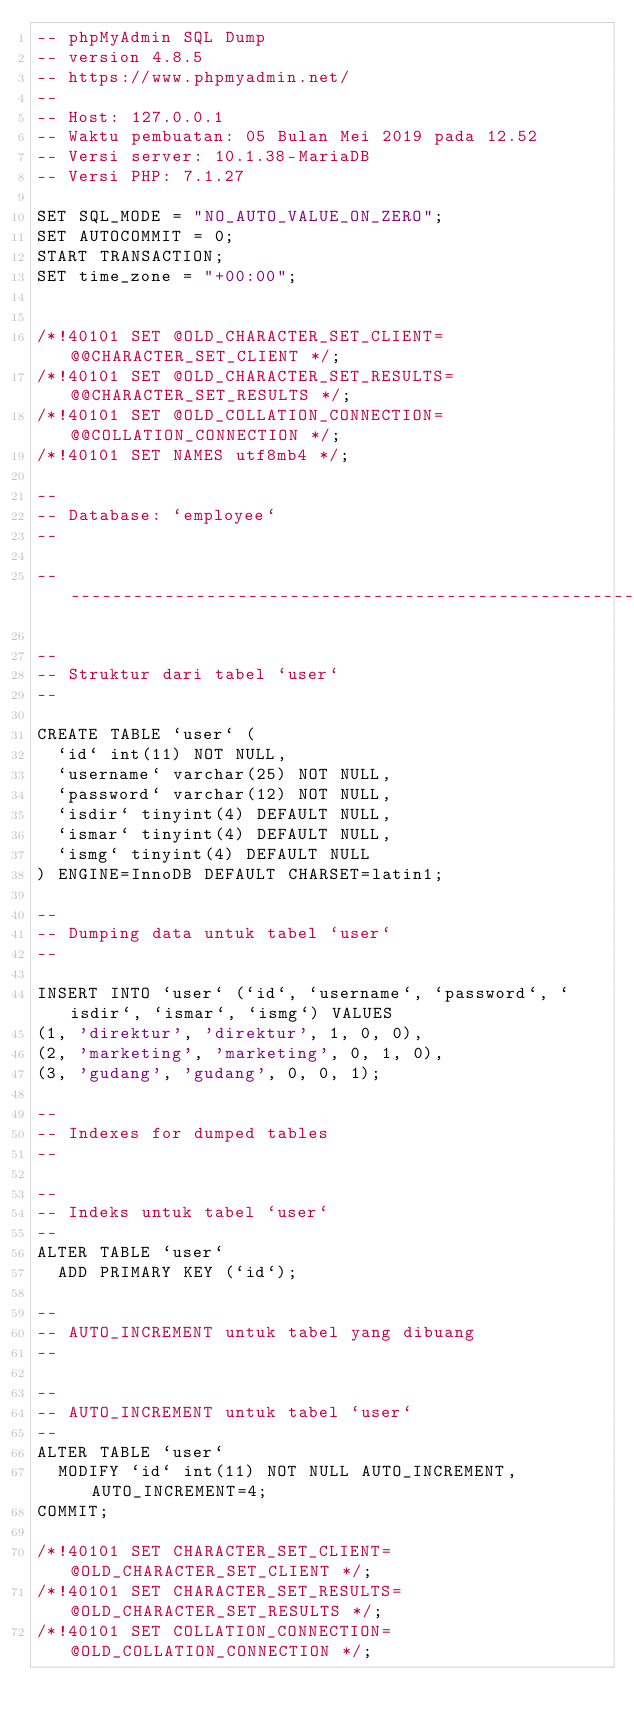Convert code to text. <code><loc_0><loc_0><loc_500><loc_500><_SQL_>-- phpMyAdmin SQL Dump
-- version 4.8.5
-- https://www.phpmyadmin.net/
--
-- Host: 127.0.0.1
-- Waktu pembuatan: 05 Bulan Mei 2019 pada 12.52
-- Versi server: 10.1.38-MariaDB
-- Versi PHP: 7.1.27

SET SQL_MODE = "NO_AUTO_VALUE_ON_ZERO";
SET AUTOCOMMIT = 0;
START TRANSACTION;
SET time_zone = "+00:00";


/*!40101 SET @OLD_CHARACTER_SET_CLIENT=@@CHARACTER_SET_CLIENT */;
/*!40101 SET @OLD_CHARACTER_SET_RESULTS=@@CHARACTER_SET_RESULTS */;
/*!40101 SET @OLD_COLLATION_CONNECTION=@@COLLATION_CONNECTION */;
/*!40101 SET NAMES utf8mb4 */;

--
-- Database: `employee`
--

-- --------------------------------------------------------

--
-- Struktur dari tabel `user`
--

CREATE TABLE `user` (
  `id` int(11) NOT NULL,
  `username` varchar(25) NOT NULL,
  `password` varchar(12) NOT NULL,
  `isdir` tinyint(4) DEFAULT NULL,
  `ismar` tinyint(4) DEFAULT NULL,
  `ismg` tinyint(4) DEFAULT NULL
) ENGINE=InnoDB DEFAULT CHARSET=latin1;

--
-- Dumping data untuk tabel `user`
--

INSERT INTO `user` (`id`, `username`, `password`, `isdir`, `ismar`, `ismg`) VALUES
(1, 'direktur', 'direktur', 1, 0, 0),
(2, 'marketing', 'marketing', 0, 1, 0),
(3, 'gudang', 'gudang', 0, 0, 1);

--
-- Indexes for dumped tables
--

--
-- Indeks untuk tabel `user`
--
ALTER TABLE `user`
  ADD PRIMARY KEY (`id`);

--
-- AUTO_INCREMENT untuk tabel yang dibuang
--

--
-- AUTO_INCREMENT untuk tabel `user`
--
ALTER TABLE `user`
  MODIFY `id` int(11) NOT NULL AUTO_INCREMENT, AUTO_INCREMENT=4;
COMMIT;

/*!40101 SET CHARACTER_SET_CLIENT=@OLD_CHARACTER_SET_CLIENT */;
/*!40101 SET CHARACTER_SET_RESULTS=@OLD_CHARACTER_SET_RESULTS */;
/*!40101 SET COLLATION_CONNECTION=@OLD_COLLATION_CONNECTION */;
</code> 